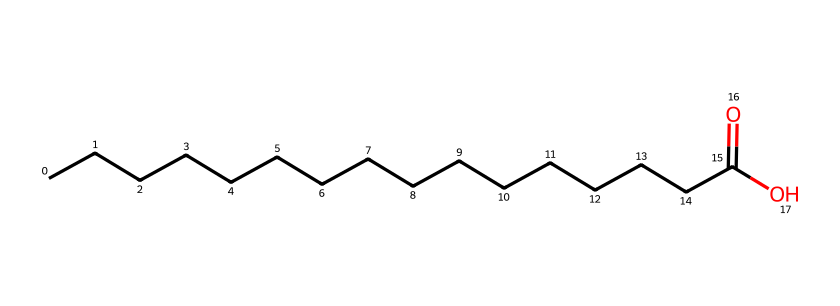What is the functional group present in this chemical? The chemical structure contains a carboxylic acid functional group, indicated by the presence of the –COOH (carboxyl) group at the end of the carbon chain.
Answer: carboxylic acid How many carbon atoms are in this fatty acid? By analyzing the SMILES representation, there are 16 carbon atoms in the longest chain (CCCCCCCCCCCCCCCC).
Answer: 16 What is the type of this acid? This chemical is a fatty acid because it consists of a long hydrocarbon chain with a carboxylic acid group, which aligns with the definitions of fatty acids.
Answer: fatty acid What is the total number of hydrogen atoms associated with this molecule? The hydrogen count can be calculated using the formula for saturated fatty acids, which is 2n + 1 + (if it is an acid subtract one hydrogen), where n is the number of carbon atoms. For 16 carbons, it would be 2(16) + 1 - 1 = 32.
Answer: 32 What is the degree of saturation of this fatty acid? This fatty acid contains no double bonds, meaning it is fully saturated; therefore, the degree of saturation is 100%.
Answer: saturated What is the molecular weight of this fatty acid? The molecular weight can be estimated by adding the atomic weights of the constituent atoms (approximately 12 for C and 1 for H, and 16 for O) that results from 16 carbons, 32 hydrogens, and 2 oxygens: (16*12) + (32*1) + (2*16) = 256 + 32 + 32 = 320.
Answer: 320 